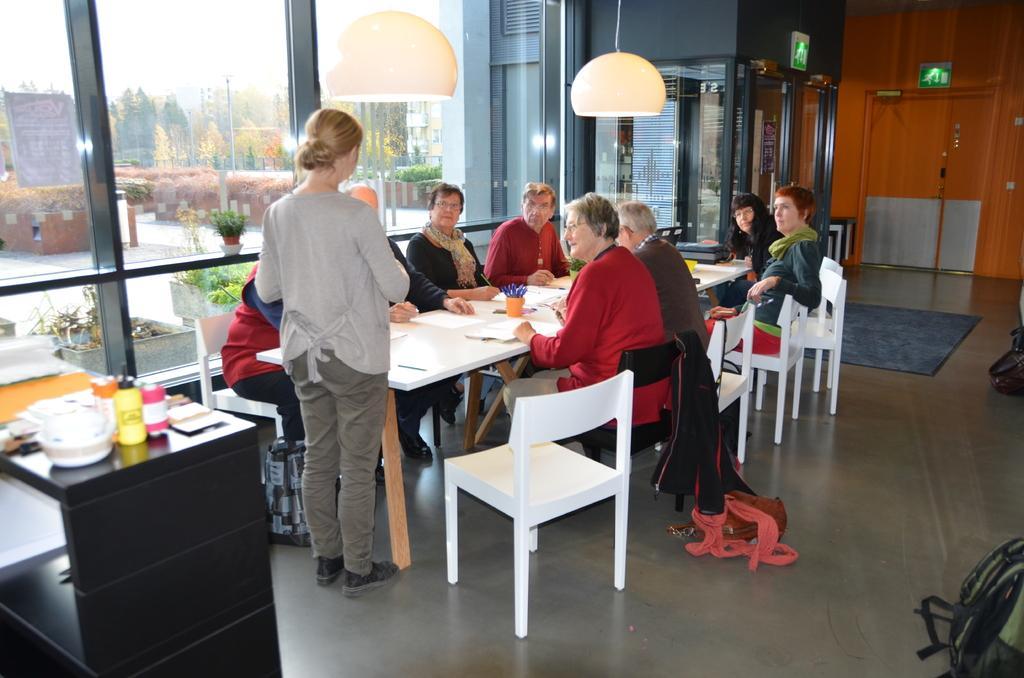Can you describe this image briefly? In this image I can see people where one is standing and rest all are sitting on chairs. I can also see few tables and on this table I can see few papers. I can also see few lights and number of trees in the background. 